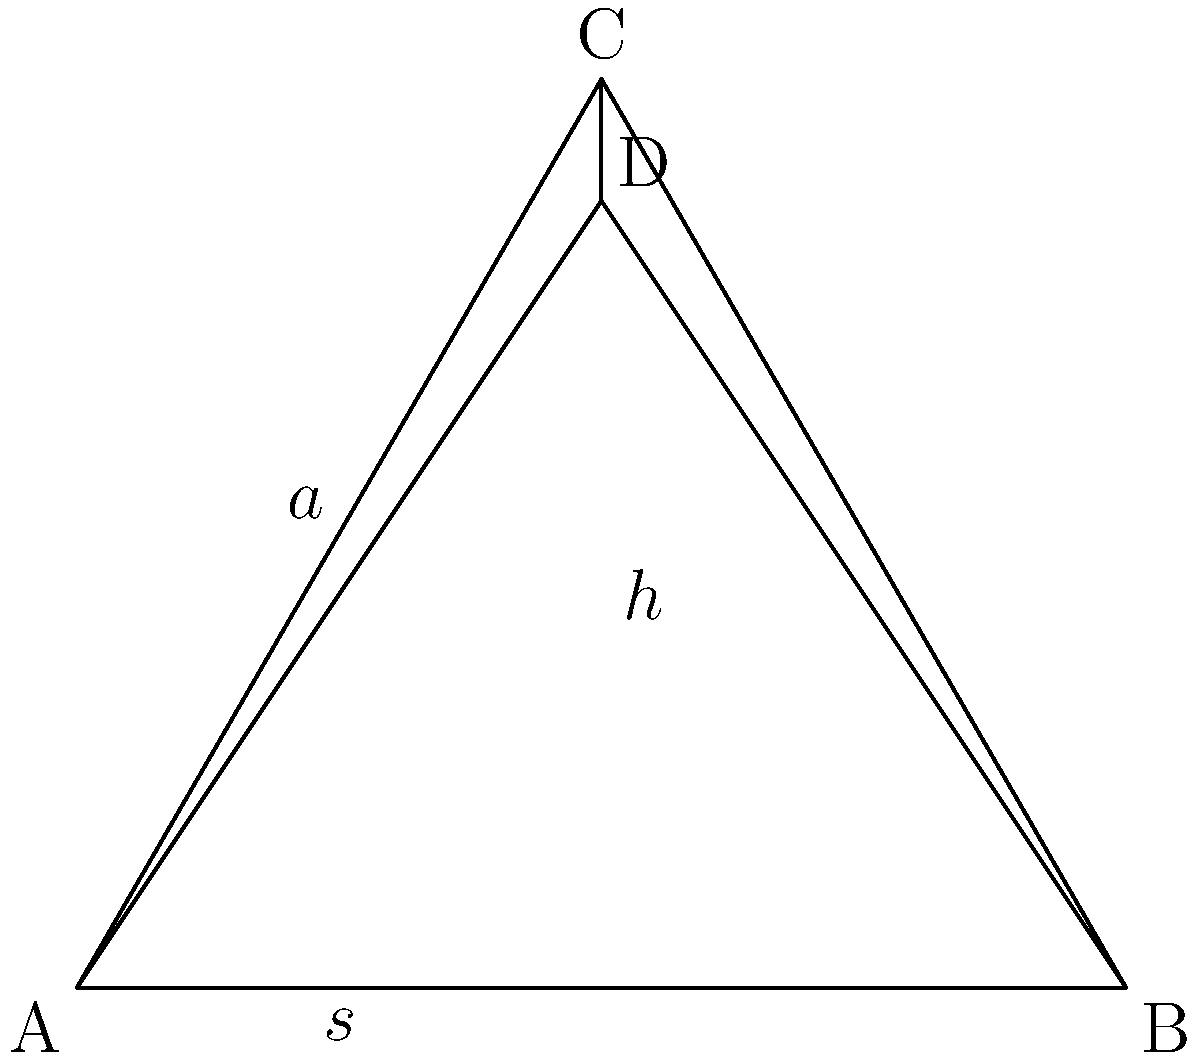In the construction of the Great Pyramid of Giza, ancient Egyptians used a technique called "seked" to measure the slope of the pyramid's faces. If the base half-width ($s$) of the pyramid is 115 meters and the height ($h$) is 146.5 meters, what is the slope angle ($\theta$) of the pyramid's face to the nearest degree? To find the slope angle of the pyramid's face, we'll follow these steps:

1) First, we need to understand that the "seked" is related to the cotangent of the slope angle. In modern terms, we're looking for $\tan(\theta)$.

2) In a right triangle formed by half the base, the height, and the slope:
   $\tan(\theta) = \frac{h}{s}$

3) We're given:
   $h = 146.5$ meters
   $s = 115$ meters

4) Substituting these values:
   $\tan(\theta) = \frac{146.5}{115}$

5) Calculate this value:
   $\tan(\theta) \approx 1.2739$

6) To find $\theta$, we need to take the inverse tangent (arctangent):
   $\theta = \arctan(1.2739)$

7) Using a calculator or computer:
   $\theta \approx 51.84$ degrees

8) Rounding to the nearest degree:
   $\theta \approx 52$ degrees

This slope angle would have allowed the ancient Egyptians to create a stable yet impressively tall structure, demonstrating their advanced understanding of geometry and engineering.
Answer: 52 degrees 